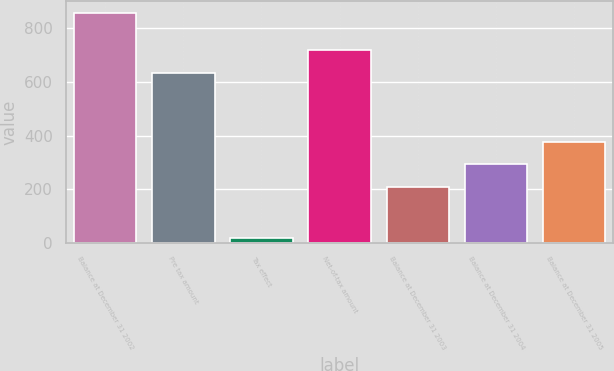<chart> <loc_0><loc_0><loc_500><loc_500><bar_chart><fcel>Balance at December 31 2002<fcel>Pre tax amount<fcel>Tax effect<fcel>Net-of-tax amount<fcel>Balance at December 31 2003<fcel>Balance at December 31 2004<fcel>Balance at December 31 2005<nl><fcel>858<fcel>634<fcel>16<fcel>718.2<fcel>208<fcel>292.2<fcel>376.4<nl></chart> 